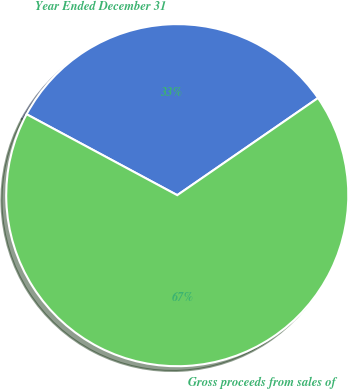<chart> <loc_0><loc_0><loc_500><loc_500><pie_chart><fcel>Year Ended December 31<fcel>Gross proceeds from sales of<nl><fcel>32.54%<fcel>67.46%<nl></chart> 